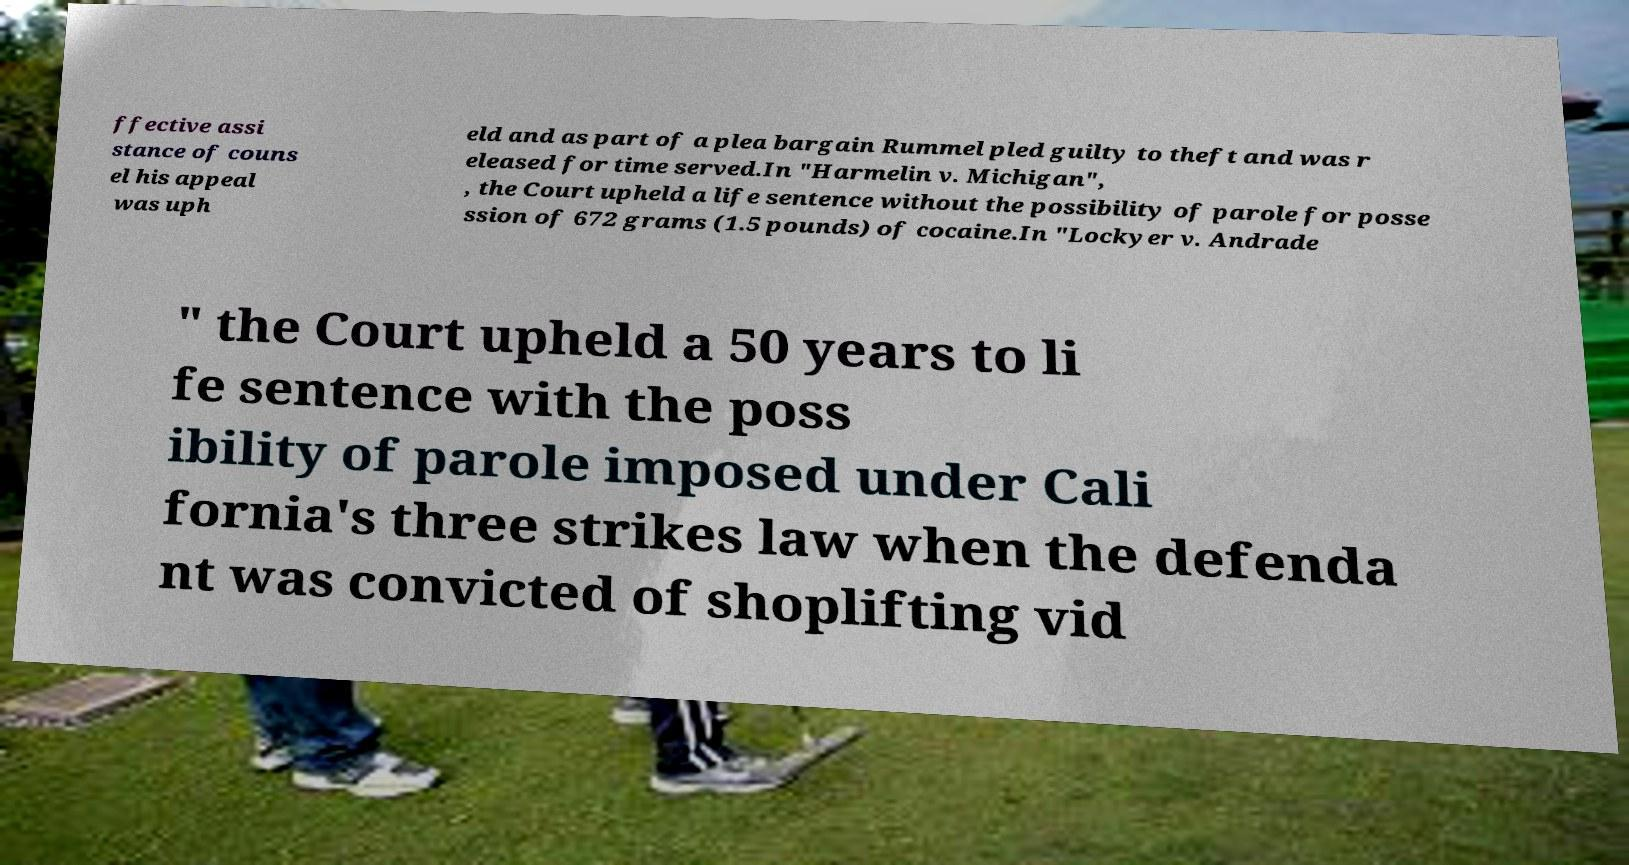Please read and relay the text visible in this image. What does it say? ffective assi stance of couns el his appeal was uph eld and as part of a plea bargain Rummel pled guilty to theft and was r eleased for time served.In "Harmelin v. Michigan", , the Court upheld a life sentence without the possibility of parole for posse ssion of 672 grams (1.5 pounds) of cocaine.In "Lockyer v. Andrade " the Court upheld a 50 years to li fe sentence with the poss ibility of parole imposed under Cali fornia's three strikes law when the defenda nt was convicted of shoplifting vid 